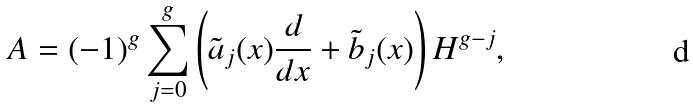Convert formula to latex. <formula><loc_0><loc_0><loc_500><loc_500>A = ( - 1 ) ^ { g } \sum _ { j = 0 } ^ { g } \left ( \tilde { a } _ { j } ( x ) \frac { d } { d x } + \tilde { b } _ { j } ( x ) \right ) H ^ { g - j } ,</formula> 